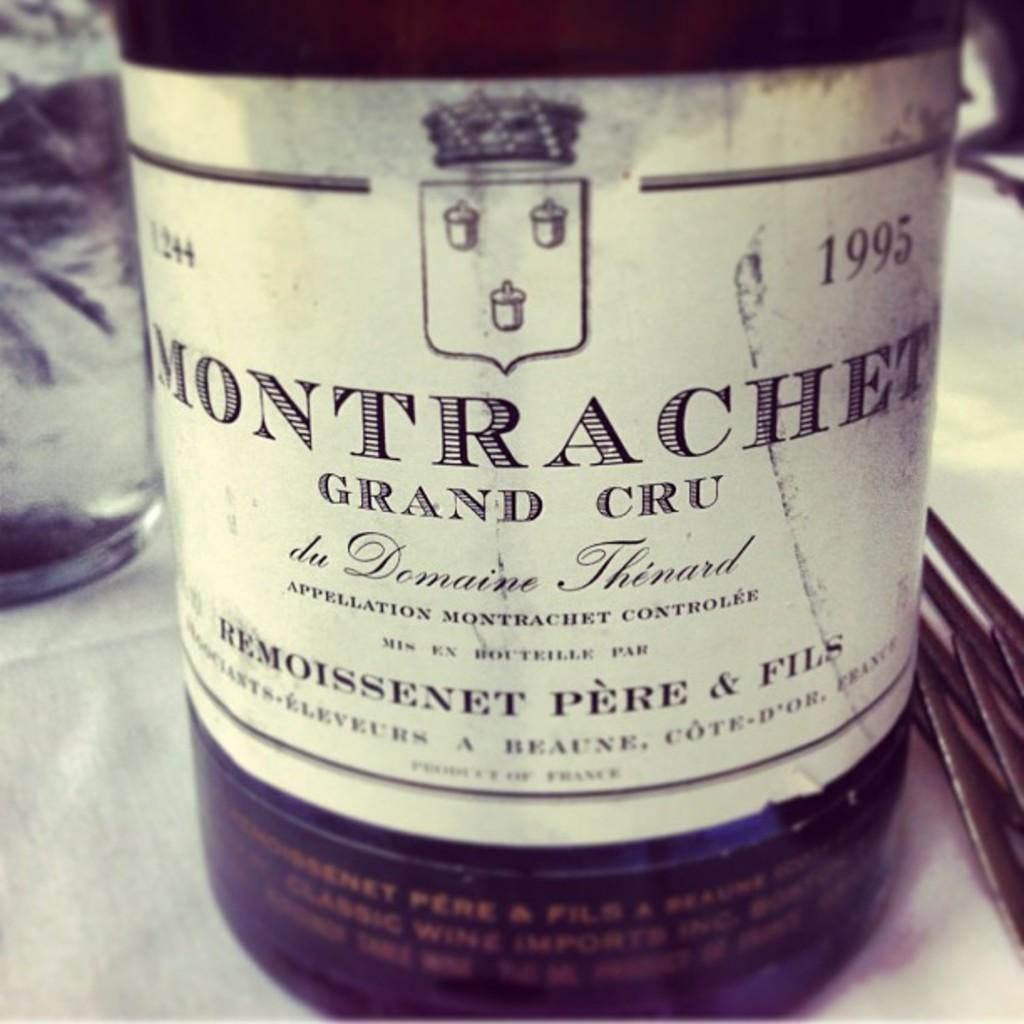<image>
Present a compact description of the photo's key features. A bottle of Montrachet Grand Cru from 1995 is displayed on a white tablecloth with silverware. 